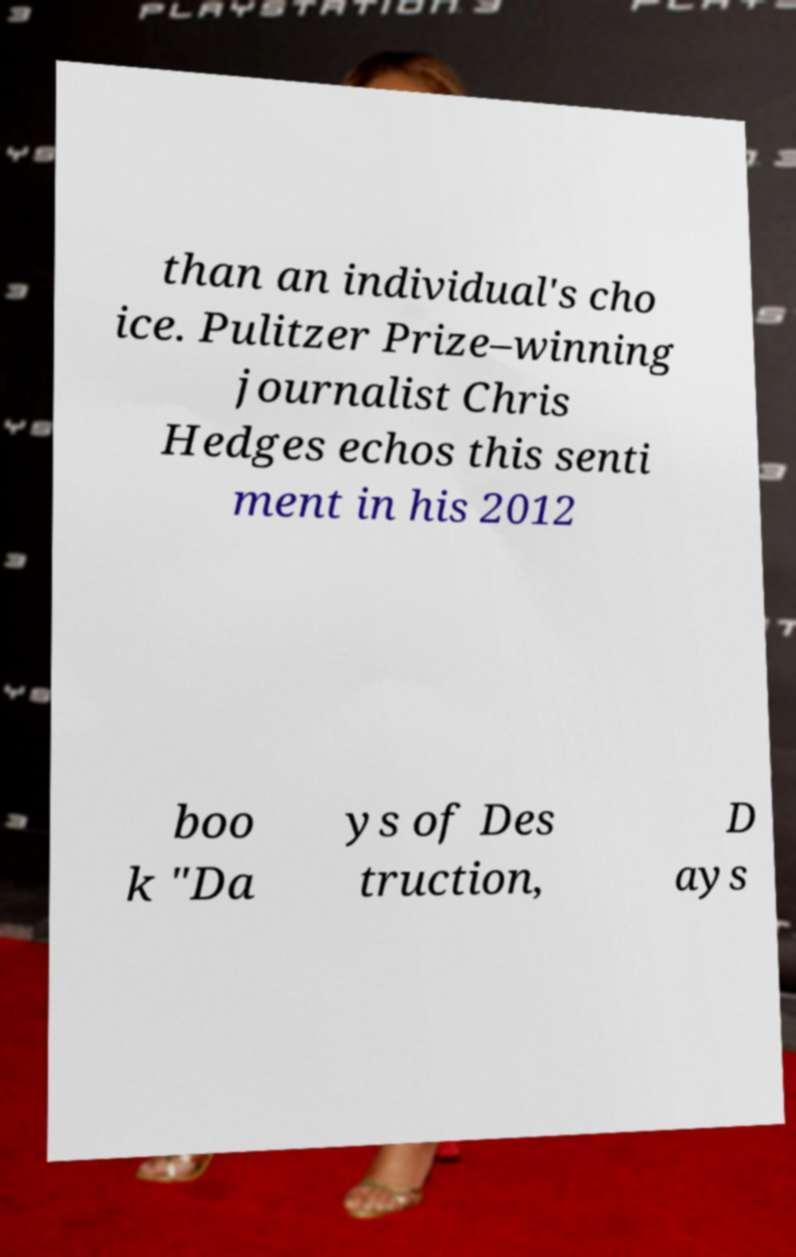Please identify and transcribe the text found in this image. than an individual's cho ice. Pulitzer Prize–winning journalist Chris Hedges echos this senti ment in his 2012 boo k "Da ys of Des truction, D ays 